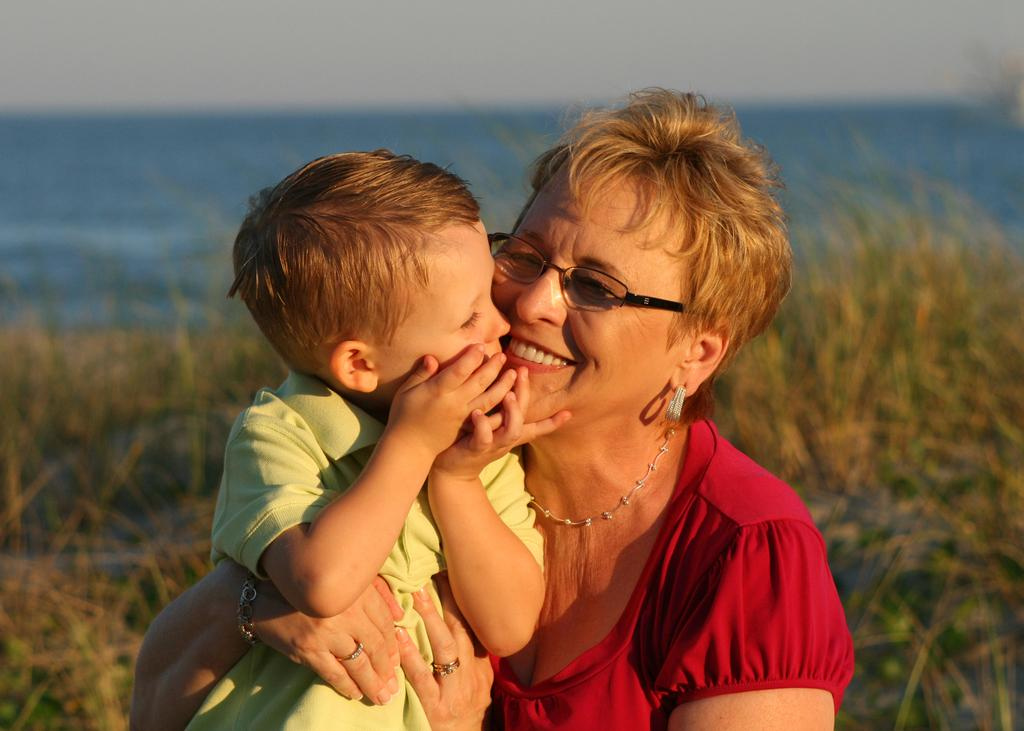Who is present in the image? There is an old lady and a kid in the image. What can be seen in the background of the image? There is grass, water, and the sky visible in the background of the image. What type of zinc is being used by the old lady in the image? There is no zinc present in the image. Is there a baseball game happening in the background of the image? There is no baseball game or any reference to baseball in the image. 